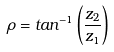<formula> <loc_0><loc_0><loc_500><loc_500>\rho = t a n ^ { - 1 } \left ( \frac { z _ { 2 } } { z _ { 1 } } \right )</formula> 